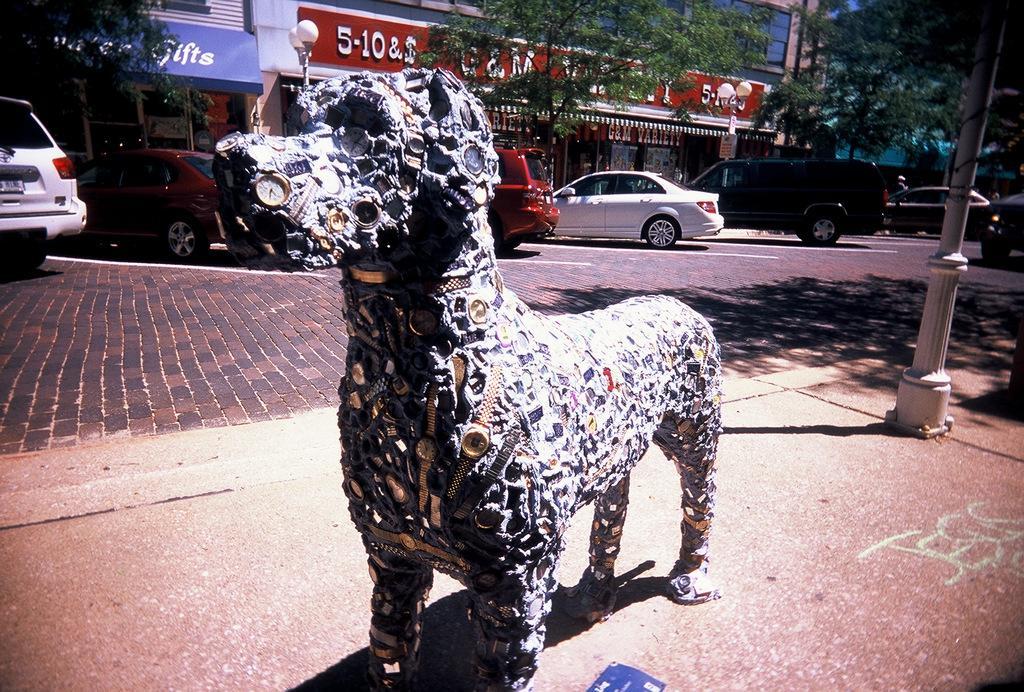Describe this image in one or two sentences. In this picture I can see a statue in the middle, in the background there are vehicles, trees, boards and buildings. 